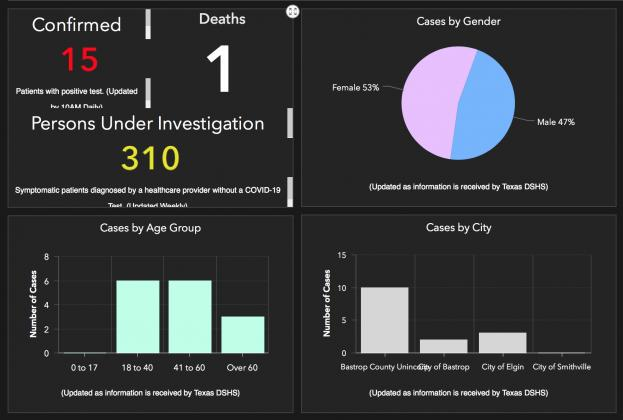Indicate a few pertinent items in this graphic. Females have been disproportionately affected by COVID-19. It can be declared that the city of Smithville has been the least affected among all the cities. The age groups of 18 to 40 and 41 to 60 have been the most severely impacted. The color of the confirmed case count is red. A total of 310 asymptomatic patients are currently under investigation. 